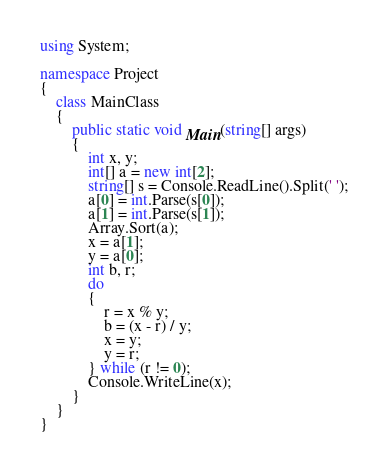<code> <loc_0><loc_0><loc_500><loc_500><_C#_>using System;

namespace Project
{
	class MainClass
	{
		public static void Main(string[] args)
		{
			int x, y;
			int[] a = new int[2];
			string[] s = Console.ReadLine().Split(' ');
			a[0] = int.Parse(s[0]);
			a[1] = int.Parse(s[1]);
			Array.Sort(a);
			x = a[1];
			y = a[0];
			int b, r;
			do
			{
				r = x % y;
				b = (x - r) / y;
				x = y;
				y = r;
			} while (r != 0);
			Console.WriteLine(x);
		}
	}
}</code> 